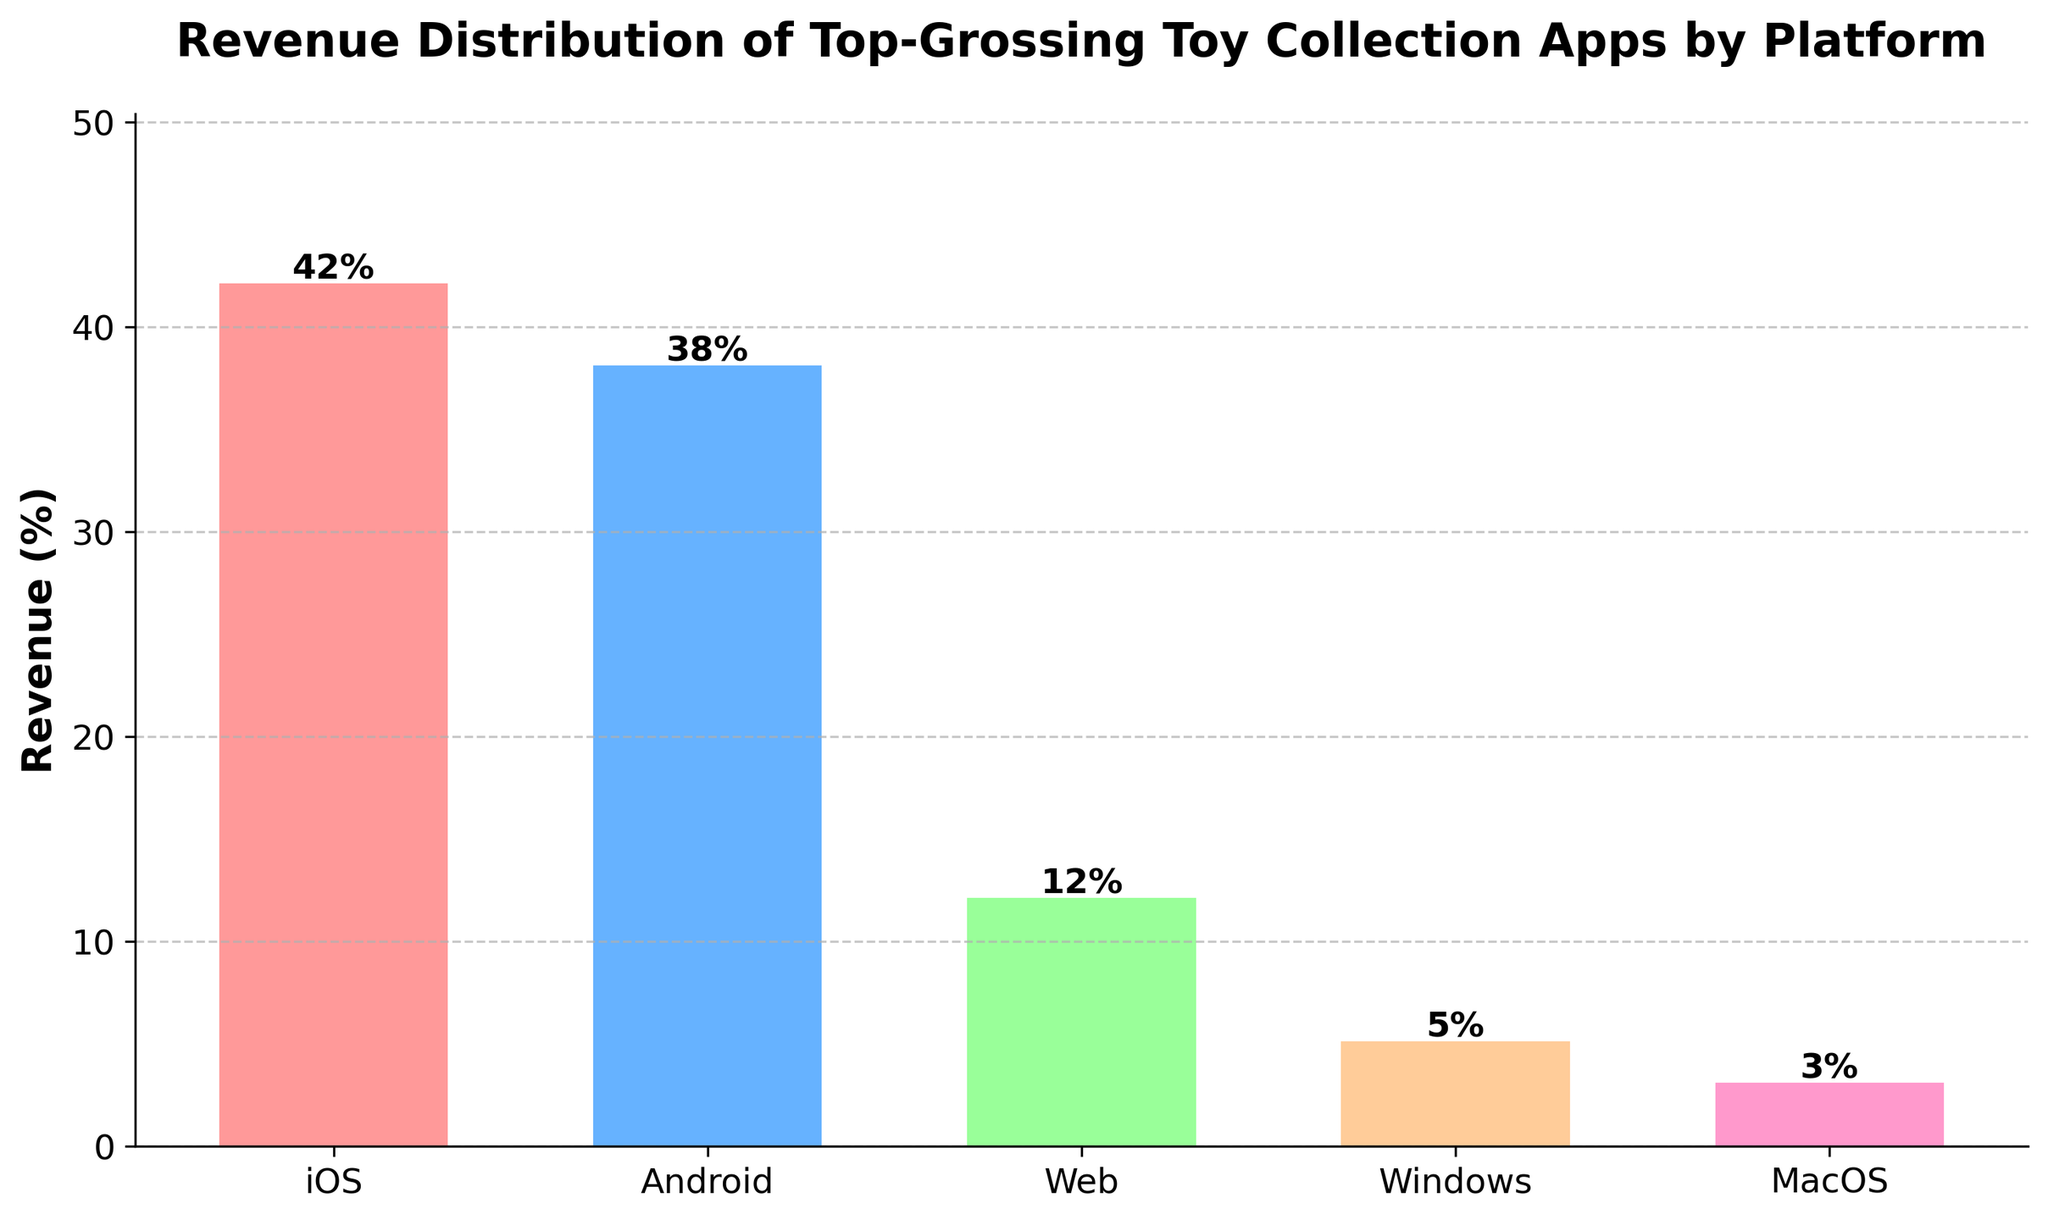How much more revenue does iOS generate compared to Android? To find out how much more revenue iOS generates compared to Android, subtract the percentage revenue of Android from that of iOS. iOS has 42% revenue, and Android has 38% revenue. So, 42% - 38% = 4%.
Answer: 4% Which platform has the smallest revenue share and by how much? Observing the bar chart, we see that MacOS has the smallest revenue share at 3%. Other platforms have higher revenues, with the next lowest being Windows at 5%. Thus, MacOS is the smallest by 5% - 3% = 2%.
Answer: MacOS, 2% What is the total revenue share of web-based and Windows platforms combined? Add the revenue percentages of the Web and Windows platforms. The Web has 12%, and Windows has 5%, so 12% + 5% = 17%.
Answer: 17% Does the iOS platform generate more revenue than Android and Web combined? Combine the revenues from Android and Web platforms. Android has 38% and Web has 12%, so 38% + 12% = 50%. Comparing this with iOS's 42%, we observe that iOS generates less revenue than Android and Web combined.
Answer: No Which platform has the second highest revenue, and what is its revenue percentage? By looking at the heights of the bars, we see iOS has the highest revenue. Android has the second highest revenue. The percentage of revenue for Android is 38%.
Answer: Android, 38% What is the revenue percentage difference between the platform with the highest revenue and the platform with the lowest revenue? The platform with the highest revenue is iOS at 42%, and the platform with the lowest revenue is MacOS at 3%. So, the difference is 42% - 3% = 39%.
Answer: 39% What is the average revenue share of all platforms represented in the chart? Sum all the revenue percentages and divide by the number of platforms to get the average. The total is 42% (iOS) + 38% (Android) + 12% (Web) + 5% (Windows) + 3% (MacOS) = 100%. Dividing by 5 gives an average of 100% / 5 = 20%.
Answer: 20% Identify the platform represented by the bar with the green color and its revenue share. By examining the bar colors, the green bar represents Android. The revenue share for Android is 38%.
Answer: Android, 38% Is the total revenue share of iOS and Android platforms more than 75%? Combine the revenue shares of iOS and Android. iOS has 42%, and Android has 38%, so 42% + 38% = 80%. Comparing with 75%, we see that their combined share is more.
Answer: Yes 